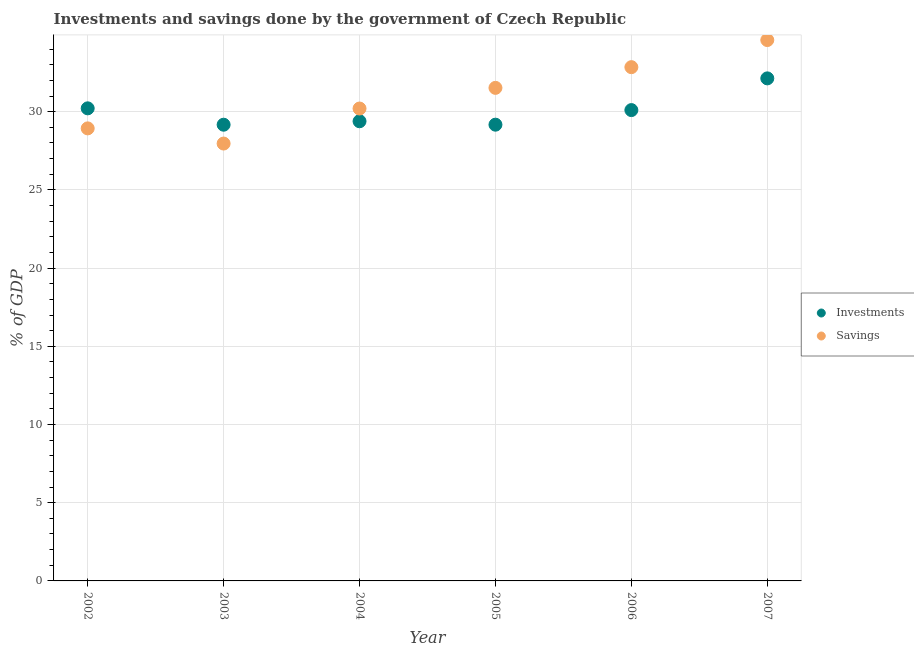What is the savings of government in 2003?
Provide a short and direct response. 27.96. Across all years, what is the maximum savings of government?
Ensure brevity in your answer.  34.58. Across all years, what is the minimum savings of government?
Your response must be concise. 27.96. In which year was the investments of government maximum?
Provide a short and direct response. 2007. What is the total investments of government in the graph?
Your response must be concise. 180.17. What is the difference between the investments of government in 2002 and that in 2003?
Give a very brief answer. 1.05. What is the difference between the savings of government in 2006 and the investments of government in 2005?
Give a very brief answer. 3.68. What is the average savings of government per year?
Provide a succinct answer. 31.01. In the year 2005, what is the difference between the savings of government and investments of government?
Provide a short and direct response. 2.35. In how many years, is the savings of government greater than 9 %?
Give a very brief answer. 6. What is the ratio of the investments of government in 2004 to that in 2006?
Your response must be concise. 0.98. Is the savings of government in 2002 less than that in 2004?
Offer a terse response. Yes. Is the difference between the investments of government in 2003 and 2007 greater than the difference between the savings of government in 2003 and 2007?
Offer a very short reply. Yes. What is the difference between the highest and the second highest savings of government?
Keep it short and to the point. 1.73. What is the difference between the highest and the lowest savings of government?
Provide a short and direct response. 6.62. In how many years, is the savings of government greater than the average savings of government taken over all years?
Provide a succinct answer. 3. Is the sum of the investments of government in 2003 and 2006 greater than the maximum savings of government across all years?
Your answer should be very brief. Yes. Does the graph contain any zero values?
Keep it short and to the point. No. How many legend labels are there?
Ensure brevity in your answer.  2. How are the legend labels stacked?
Keep it short and to the point. Vertical. What is the title of the graph?
Keep it short and to the point. Investments and savings done by the government of Czech Republic. Does "Age 65(female)" appear as one of the legend labels in the graph?
Your answer should be compact. No. What is the label or title of the Y-axis?
Offer a very short reply. % of GDP. What is the % of GDP of Investments in 2002?
Your response must be concise. 30.21. What is the % of GDP in Savings in 2002?
Your response must be concise. 28.93. What is the % of GDP of Investments in 2003?
Keep it short and to the point. 29.17. What is the % of GDP of Savings in 2003?
Your answer should be compact. 27.96. What is the % of GDP of Investments in 2004?
Your answer should be very brief. 29.39. What is the % of GDP in Savings in 2004?
Provide a short and direct response. 30.2. What is the % of GDP in Investments in 2005?
Offer a very short reply. 29.17. What is the % of GDP in Savings in 2005?
Provide a succinct answer. 31.52. What is the % of GDP in Investments in 2006?
Your response must be concise. 30.1. What is the % of GDP in Savings in 2006?
Offer a very short reply. 32.85. What is the % of GDP in Investments in 2007?
Give a very brief answer. 32.13. What is the % of GDP in Savings in 2007?
Your answer should be compact. 34.58. Across all years, what is the maximum % of GDP of Investments?
Ensure brevity in your answer.  32.13. Across all years, what is the maximum % of GDP of Savings?
Make the answer very short. 34.58. Across all years, what is the minimum % of GDP in Investments?
Your answer should be very brief. 29.17. Across all years, what is the minimum % of GDP in Savings?
Keep it short and to the point. 27.96. What is the total % of GDP in Investments in the graph?
Provide a succinct answer. 180.17. What is the total % of GDP of Savings in the graph?
Keep it short and to the point. 186.04. What is the difference between the % of GDP of Investments in 2002 and that in 2003?
Provide a short and direct response. 1.05. What is the difference between the % of GDP of Savings in 2002 and that in 2003?
Make the answer very short. 0.97. What is the difference between the % of GDP of Investments in 2002 and that in 2004?
Keep it short and to the point. 0.83. What is the difference between the % of GDP of Savings in 2002 and that in 2004?
Provide a succinct answer. -1.27. What is the difference between the % of GDP in Investments in 2002 and that in 2005?
Your answer should be compact. 1.04. What is the difference between the % of GDP of Savings in 2002 and that in 2005?
Your answer should be compact. -2.59. What is the difference between the % of GDP of Investments in 2002 and that in 2006?
Keep it short and to the point. 0.11. What is the difference between the % of GDP of Savings in 2002 and that in 2006?
Offer a very short reply. -3.91. What is the difference between the % of GDP in Investments in 2002 and that in 2007?
Make the answer very short. -1.92. What is the difference between the % of GDP of Savings in 2002 and that in 2007?
Your response must be concise. -5.65. What is the difference between the % of GDP in Investments in 2003 and that in 2004?
Your answer should be very brief. -0.22. What is the difference between the % of GDP of Savings in 2003 and that in 2004?
Offer a very short reply. -2.24. What is the difference between the % of GDP in Investments in 2003 and that in 2005?
Your answer should be very brief. -0. What is the difference between the % of GDP in Savings in 2003 and that in 2005?
Provide a short and direct response. -3.56. What is the difference between the % of GDP in Investments in 2003 and that in 2006?
Keep it short and to the point. -0.93. What is the difference between the % of GDP of Savings in 2003 and that in 2006?
Keep it short and to the point. -4.88. What is the difference between the % of GDP of Investments in 2003 and that in 2007?
Offer a terse response. -2.96. What is the difference between the % of GDP of Savings in 2003 and that in 2007?
Provide a succinct answer. -6.62. What is the difference between the % of GDP of Investments in 2004 and that in 2005?
Ensure brevity in your answer.  0.22. What is the difference between the % of GDP of Savings in 2004 and that in 2005?
Offer a very short reply. -1.32. What is the difference between the % of GDP of Investments in 2004 and that in 2006?
Provide a succinct answer. -0.71. What is the difference between the % of GDP of Savings in 2004 and that in 2006?
Give a very brief answer. -2.64. What is the difference between the % of GDP in Investments in 2004 and that in 2007?
Your answer should be very brief. -2.74. What is the difference between the % of GDP in Savings in 2004 and that in 2007?
Offer a terse response. -4.38. What is the difference between the % of GDP in Investments in 2005 and that in 2006?
Your answer should be compact. -0.93. What is the difference between the % of GDP of Savings in 2005 and that in 2006?
Ensure brevity in your answer.  -1.32. What is the difference between the % of GDP in Investments in 2005 and that in 2007?
Ensure brevity in your answer.  -2.96. What is the difference between the % of GDP in Savings in 2005 and that in 2007?
Provide a succinct answer. -3.06. What is the difference between the % of GDP in Investments in 2006 and that in 2007?
Provide a short and direct response. -2.03. What is the difference between the % of GDP of Savings in 2006 and that in 2007?
Offer a very short reply. -1.73. What is the difference between the % of GDP in Investments in 2002 and the % of GDP in Savings in 2003?
Keep it short and to the point. 2.25. What is the difference between the % of GDP of Investments in 2002 and the % of GDP of Savings in 2004?
Ensure brevity in your answer.  0.01. What is the difference between the % of GDP in Investments in 2002 and the % of GDP in Savings in 2005?
Your response must be concise. -1.31. What is the difference between the % of GDP of Investments in 2002 and the % of GDP of Savings in 2006?
Ensure brevity in your answer.  -2.63. What is the difference between the % of GDP of Investments in 2002 and the % of GDP of Savings in 2007?
Offer a very short reply. -4.37. What is the difference between the % of GDP in Investments in 2003 and the % of GDP in Savings in 2004?
Keep it short and to the point. -1.03. What is the difference between the % of GDP of Investments in 2003 and the % of GDP of Savings in 2005?
Provide a succinct answer. -2.36. What is the difference between the % of GDP in Investments in 2003 and the % of GDP in Savings in 2006?
Give a very brief answer. -3.68. What is the difference between the % of GDP in Investments in 2003 and the % of GDP in Savings in 2007?
Ensure brevity in your answer.  -5.41. What is the difference between the % of GDP of Investments in 2004 and the % of GDP of Savings in 2005?
Give a very brief answer. -2.13. What is the difference between the % of GDP of Investments in 2004 and the % of GDP of Savings in 2006?
Keep it short and to the point. -3.46. What is the difference between the % of GDP in Investments in 2004 and the % of GDP in Savings in 2007?
Keep it short and to the point. -5.19. What is the difference between the % of GDP in Investments in 2005 and the % of GDP in Savings in 2006?
Your answer should be compact. -3.68. What is the difference between the % of GDP in Investments in 2005 and the % of GDP in Savings in 2007?
Your answer should be very brief. -5.41. What is the difference between the % of GDP in Investments in 2006 and the % of GDP in Savings in 2007?
Ensure brevity in your answer.  -4.48. What is the average % of GDP in Investments per year?
Give a very brief answer. 30.03. What is the average % of GDP of Savings per year?
Offer a terse response. 31.01. In the year 2002, what is the difference between the % of GDP of Investments and % of GDP of Savings?
Ensure brevity in your answer.  1.28. In the year 2003, what is the difference between the % of GDP of Investments and % of GDP of Savings?
Make the answer very short. 1.2. In the year 2004, what is the difference between the % of GDP in Investments and % of GDP in Savings?
Keep it short and to the point. -0.81. In the year 2005, what is the difference between the % of GDP of Investments and % of GDP of Savings?
Offer a very short reply. -2.35. In the year 2006, what is the difference between the % of GDP of Investments and % of GDP of Savings?
Provide a succinct answer. -2.74. In the year 2007, what is the difference between the % of GDP in Investments and % of GDP in Savings?
Provide a succinct answer. -2.45. What is the ratio of the % of GDP in Investments in 2002 to that in 2003?
Keep it short and to the point. 1.04. What is the ratio of the % of GDP of Savings in 2002 to that in 2003?
Keep it short and to the point. 1.03. What is the ratio of the % of GDP in Investments in 2002 to that in 2004?
Your answer should be very brief. 1.03. What is the ratio of the % of GDP of Savings in 2002 to that in 2004?
Provide a short and direct response. 0.96. What is the ratio of the % of GDP in Investments in 2002 to that in 2005?
Give a very brief answer. 1.04. What is the ratio of the % of GDP in Savings in 2002 to that in 2005?
Your response must be concise. 0.92. What is the ratio of the % of GDP in Investments in 2002 to that in 2006?
Ensure brevity in your answer.  1. What is the ratio of the % of GDP in Savings in 2002 to that in 2006?
Offer a very short reply. 0.88. What is the ratio of the % of GDP of Investments in 2002 to that in 2007?
Ensure brevity in your answer.  0.94. What is the ratio of the % of GDP in Savings in 2002 to that in 2007?
Make the answer very short. 0.84. What is the ratio of the % of GDP in Investments in 2003 to that in 2004?
Provide a short and direct response. 0.99. What is the ratio of the % of GDP in Savings in 2003 to that in 2004?
Keep it short and to the point. 0.93. What is the ratio of the % of GDP in Savings in 2003 to that in 2005?
Offer a terse response. 0.89. What is the ratio of the % of GDP of Investments in 2003 to that in 2006?
Your answer should be very brief. 0.97. What is the ratio of the % of GDP in Savings in 2003 to that in 2006?
Ensure brevity in your answer.  0.85. What is the ratio of the % of GDP in Investments in 2003 to that in 2007?
Your answer should be very brief. 0.91. What is the ratio of the % of GDP in Savings in 2003 to that in 2007?
Provide a succinct answer. 0.81. What is the ratio of the % of GDP in Investments in 2004 to that in 2005?
Your answer should be compact. 1.01. What is the ratio of the % of GDP of Savings in 2004 to that in 2005?
Provide a short and direct response. 0.96. What is the ratio of the % of GDP in Investments in 2004 to that in 2006?
Your response must be concise. 0.98. What is the ratio of the % of GDP in Savings in 2004 to that in 2006?
Provide a short and direct response. 0.92. What is the ratio of the % of GDP of Investments in 2004 to that in 2007?
Your answer should be compact. 0.91. What is the ratio of the % of GDP of Savings in 2004 to that in 2007?
Your response must be concise. 0.87. What is the ratio of the % of GDP of Investments in 2005 to that in 2006?
Give a very brief answer. 0.97. What is the ratio of the % of GDP in Savings in 2005 to that in 2006?
Your answer should be compact. 0.96. What is the ratio of the % of GDP in Investments in 2005 to that in 2007?
Your response must be concise. 0.91. What is the ratio of the % of GDP of Savings in 2005 to that in 2007?
Offer a very short reply. 0.91. What is the ratio of the % of GDP in Investments in 2006 to that in 2007?
Provide a short and direct response. 0.94. What is the ratio of the % of GDP of Savings in 2006 to that in 2007?
Provide a succinct answer. 0.95. What is the difference between the highest and the second highest % of GDP of Investments?
Provide a succinct answer. 1.92. What is the difference between the highest and the second highest % of GDP of Savings?
Your answer should be compact. 1.73. What is the difference between the highest and the lowest % of GDP of Investments?
Provide a succinct answer. 2.96. What is the difference between the highest and the lowest % of GDP in Savings?
Your answer should be very brief. 6.62. 